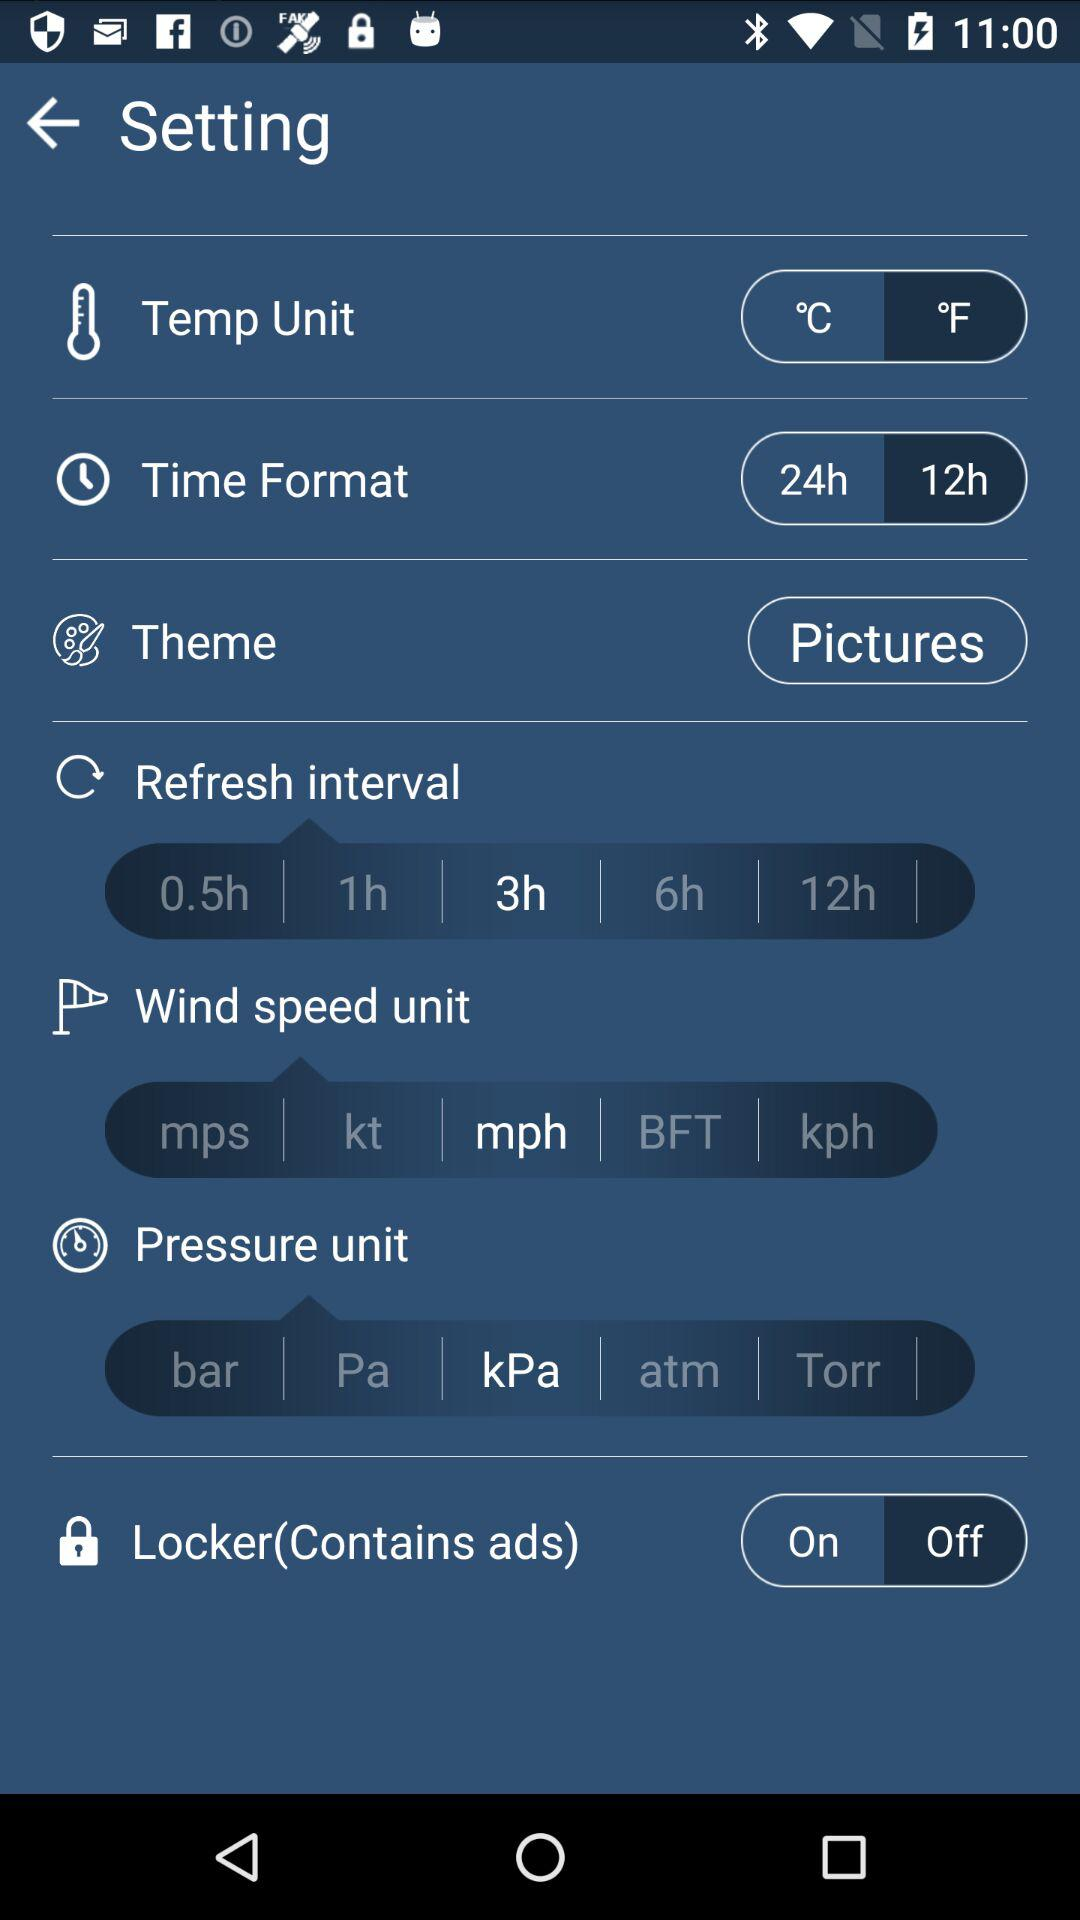What unit of pressure is selected? The selected unit of pressure is kPa. 